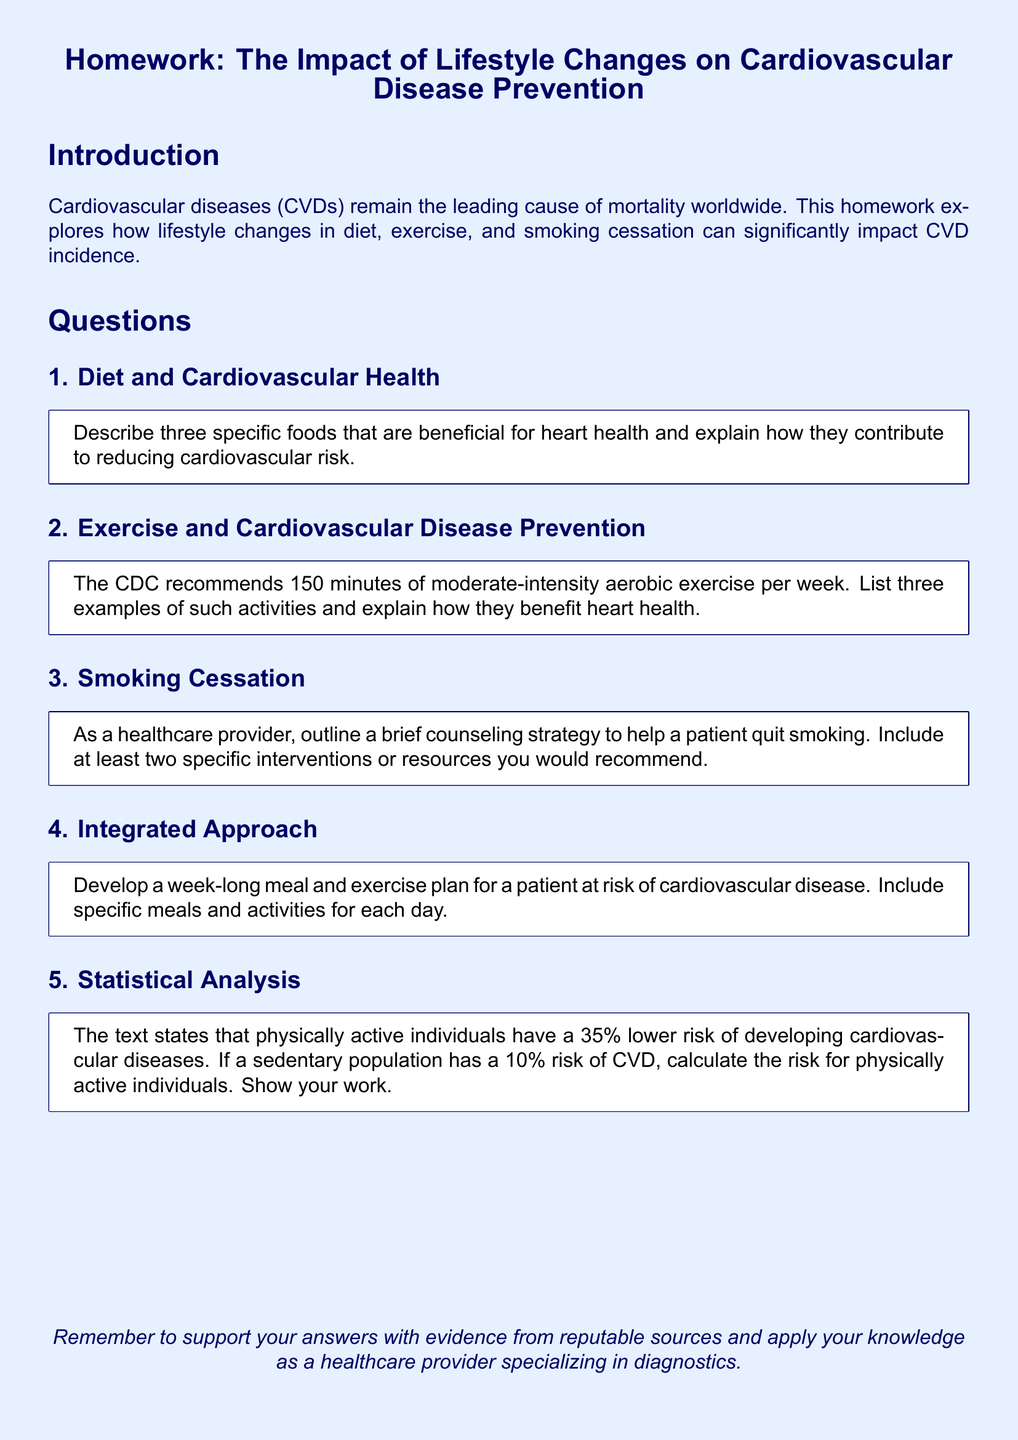What is the primary focus of the homework? The homework explores how lifestyle changes in diet, exercise, and smoking cessation can significantly impact CVD incidence.
Answer: CVD incidence What is recommended to be done weekly for heart health? The CDC recommends 150 minutes of moderate-intensity aerobic exercise per week for cardiovascular health.
Answer: 150 minutes Name one specific food mentioned that is beneficial for heart health. The question asks to describe beneficial foods, but the homework itself provides no specific names; it requires the respondent to identify three.
Answer: Not specified What is the risk reduction percentage for physically active individuals? The text states that physically active individuals have a 35% lower risk of developing cardiovascular diseases.
Answer: 35% How many examples of moderate-intensity aerobic exercises should be listed? The question requests three examples to explain their benefits for heart health.
Answer: Three What is one intervention that can help a patient quit smoking? The homework suggests outlining a counseling strategy for smoking cessation which includes specific interventions but does not specify them; it requires the respondent to identify at least two.
Answer: Not specified What type of plan should be developed in question 4? The fourth question requires development of a week-long meal and exercise plan tailored for a patient at risk.
Answer: Meal and exercise plan What is expected to support the answers in the document? The document advises to support answers with evidence from reputable sources.
Answer: Reputable sources 